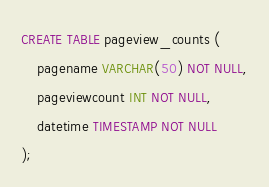<code> <loc_0><loc_0><loc_500><loc_500><_SQL_>CREATE TABLE pageview_counts (
    pagename VARCHAR(50) NOT NULL,
    pageviewcount INT NOT NULL,
    datetime TIMESTAMP NOT NULL
);
</code> 